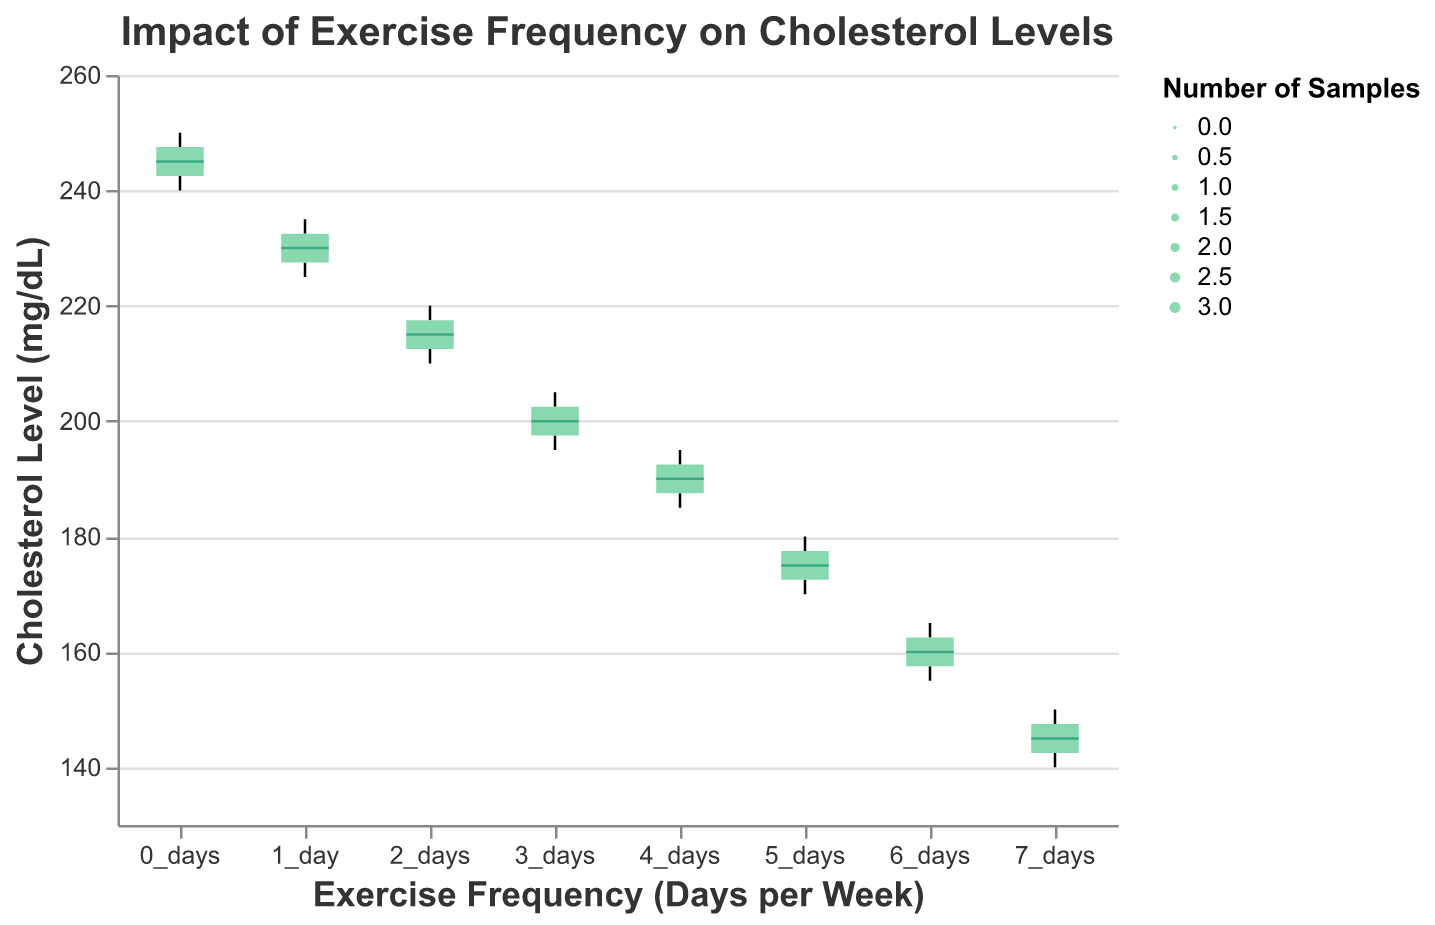what is the title of the plot? The title is usually placed at the top of the plot and it provides a brief description of what the plot is about. The title in this plot reads "Impact of Exercise Frequency on Cholesterol Levels."
Answer: Impact of Exercise Frequency on Cholesterol Levels How many days per week does the exercise frequency range from? The x-axis of the plot shows the categories representing exercise frequency. In the given plot, the categories range from "0_days" to "7_days".
Answer: 0_days to 7_days What does the y-axis represent in this plot? The y-axis in the plot represents the variable being measured to see its relationship with exercise frequency. From the plot, it is clear that the y-axis denotes "Cholesterol Level (mg/dL)."
Answer: Cholesterol Level (mg/dL) What is the color of the median line in the box plots? The median line within each box plot is highlighted in a distinct color to differentiate it from the rest of the elements. In this plot, the median lines are colored in a dark green shade.
Answer: Dark green Which exercise frequency has the lowest median cholesterol level? To find this, we look at the median line within each box plot and identify the one that is situated at the lowest y-axis position. The "7_days" frequency has the median line at the lowest position, indicating the lowest median cholesterol level.
Answer: 7_days Which exercise frequency shows the highest variation in cholesterol levels? The range of the box plot, represented by the length of the whiskers, indicates the variation. The "0_days" frequency has the most extended whiskers, indicating it has the highest variation in cholesterol levels.
Answer: 0_days What is the approximate cholesterol level range for individuals who exercise "3_days" a week? To determine this, we observe the upper and lower bounds of the whiskers for "3_days". The range appears to be approximately from 195 mg/dL to 205 mg/dL.
Answer: 195 mg/dL to 205 mg/dL What can be said about the trend in cholesterol levels as exercise frequency increases? By looking at the box plots from "0_days" to "7_days", there is a general downward trend in the median positions of the box plots, indicating that higher exercise frequency leads to lower cholesterol levels.
Answer: Cholesterol levels generally decrease as exercise frequency increases Which exercise frequency has the highest number of samples? The width of the box plots represents the number of samples. The box plot for "7_days" is the widest, indicating it has the highest number of samples.
Answer: 7_days How does the median cholesterol level for "5_days" compare to "2_days"? Reviewing the median lines in their respective box plots, "5_days" has a lower median cholesterol level than "2_days", showcasing an improvement in cholesterol levels with increased exercise days.
Answer: 5_days is lower than 2_days 